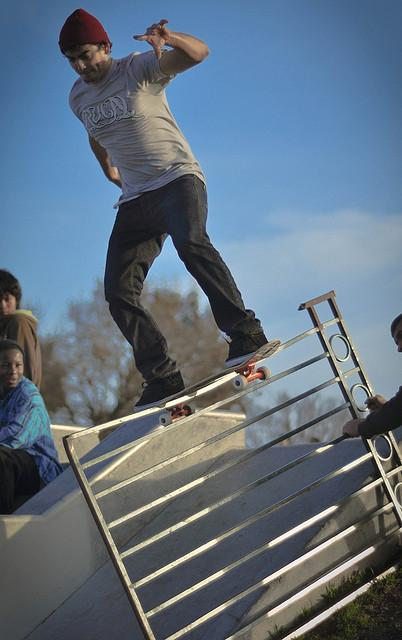Why is the man on top of the railing? skateboarding 